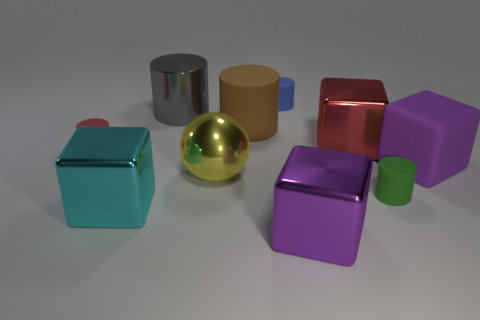Add 6 small matte objects. How many small matte objects exist? 9 Subtract all red cylinders. How many cylinders are left? 4 Subtract all big gray metallic cylinders. How many cylinders are left? 4 Subtract 0 purple cylinders. How many objects are left? 10 Subtract all spheres. How many objects are left? 9 Subtract 1 cylinders. How many cylinders are left? 4 Subtract all purple spheres. Subtract all purple cylinders. How many spheres are left? 1 Subtract all brown cylinders. How many brown spheres are left? 0 Subtract all green metallic cylinders. Subtract all tiny green objects. How many objects are left? 9 Add 5 purple rubber cubes. How many purple rubber cubes are left? 6 